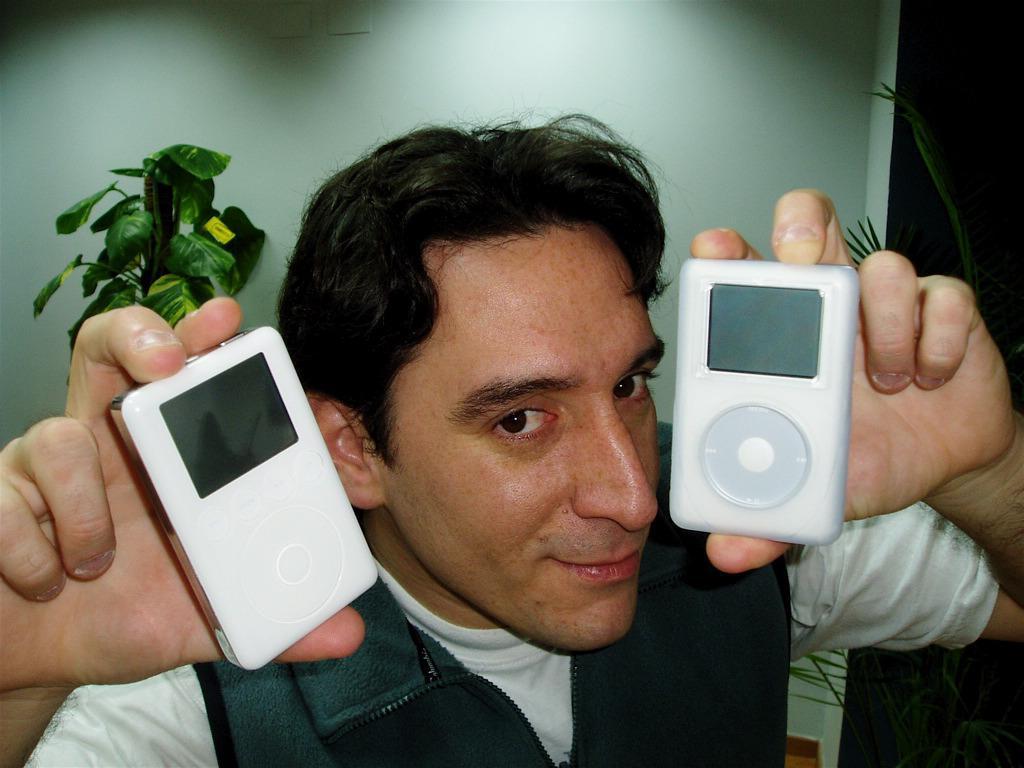In one or two sentences, can you explain what this image depicts? In the picture there is a man, he is holding two ipads with his hands and behind the man there are two plants and behind the plants there is a wall. 